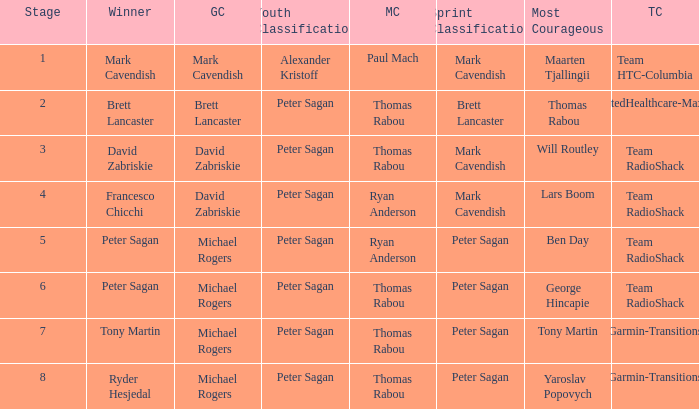When Brett Lancaster won the general classification, who won the team calssification? UnitedHealthcare-Maxxis. 